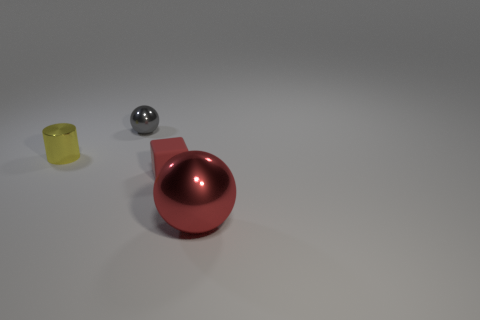Subtract all red balls. How many balls are left? 1 Add 4 small yellow metallic cylinders. How many objects exist? 8 Add 1 red metallic balls. How many red metallic balls are left? 2 Add 4 large blue matte spheres. How many large blue matte spheres exist? 4 Subtract 0 yellow spheres. How many objects are left? 4 Subtract all cubes. How many objects are left? 3 Subtract all green spheres. Subtract all red cylinders. How many spheres are left? 2 Subtract all brown cylinders. How many gray spheres are left? 1 Subtract all red shiny spheres. Subtract all gray shiny spheres. How many objects are left? 2 